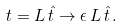<formula> <loc_0><loc_0><loc_500><loc_500>t = L \, \hat { t } \to \epsilon \, L \, \hat { t } \, .</formula> 